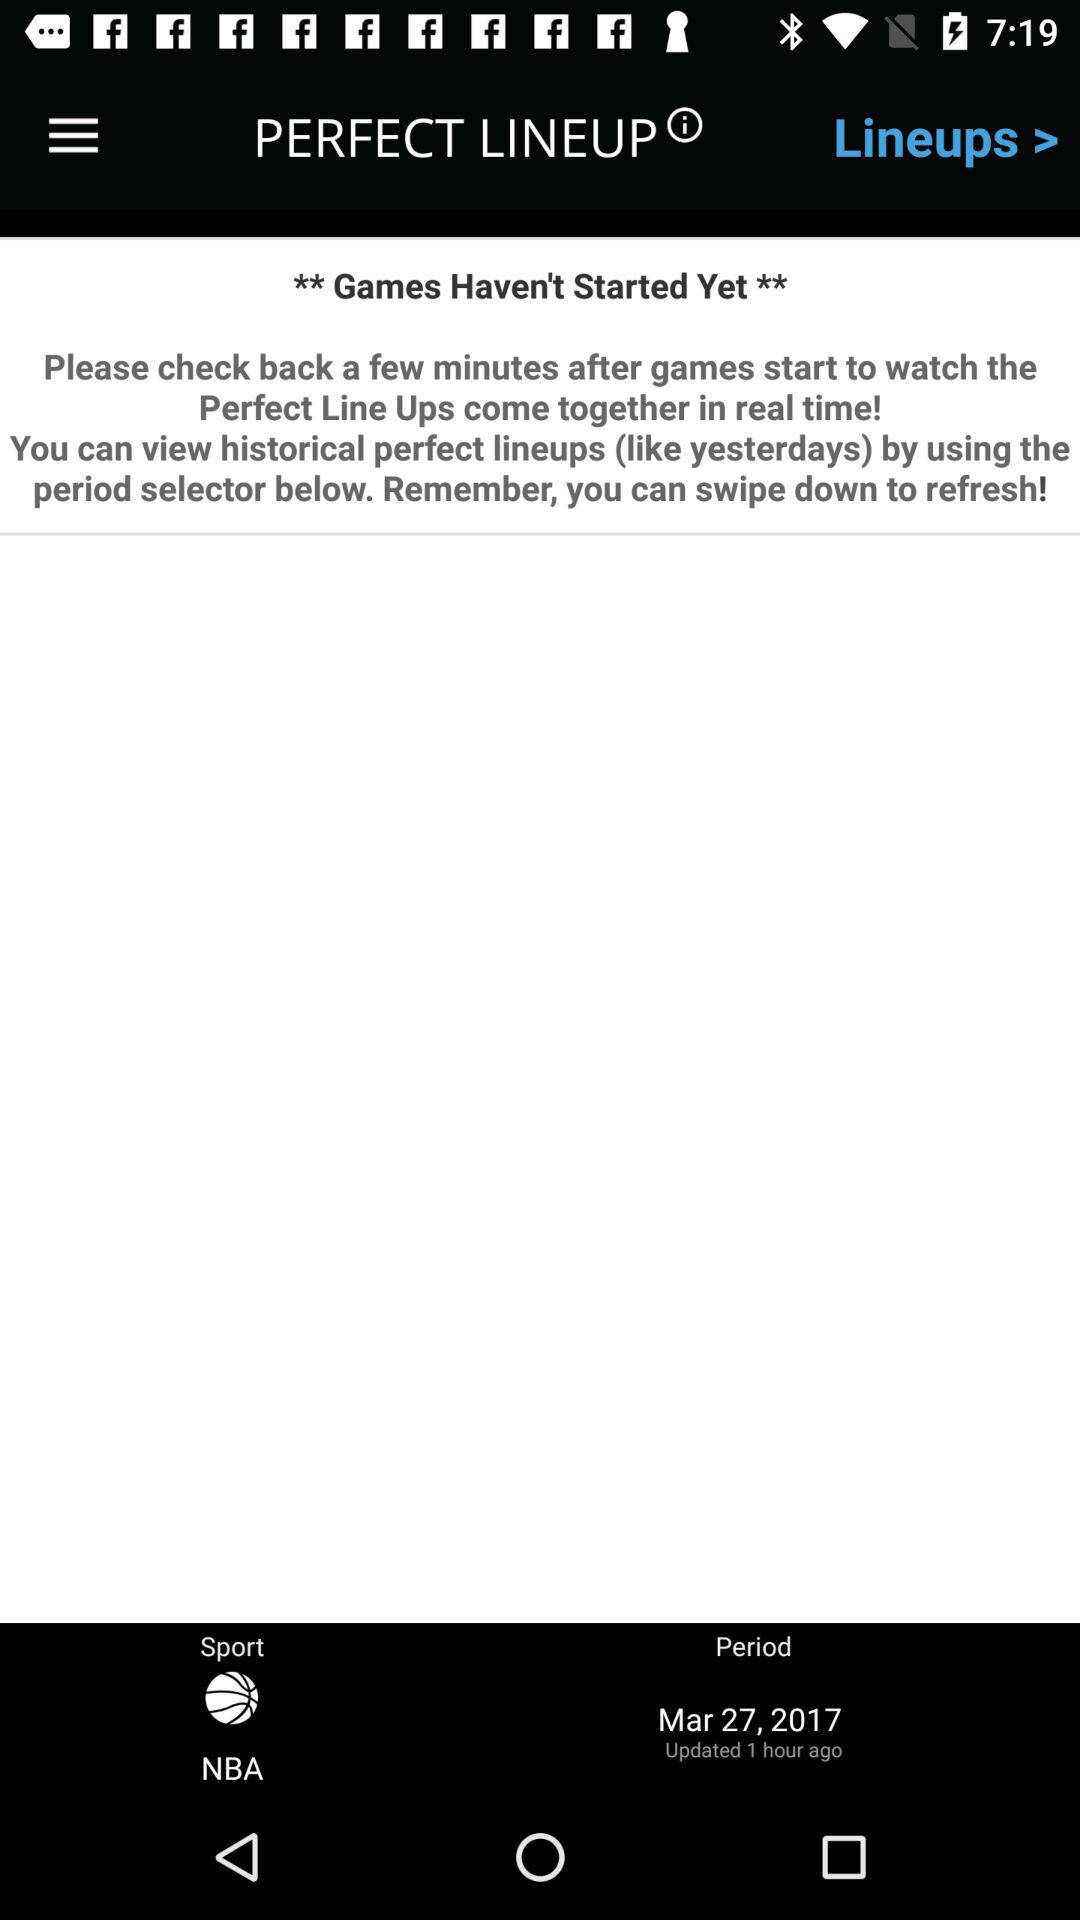What is the date? The date is March 27, 2017. 